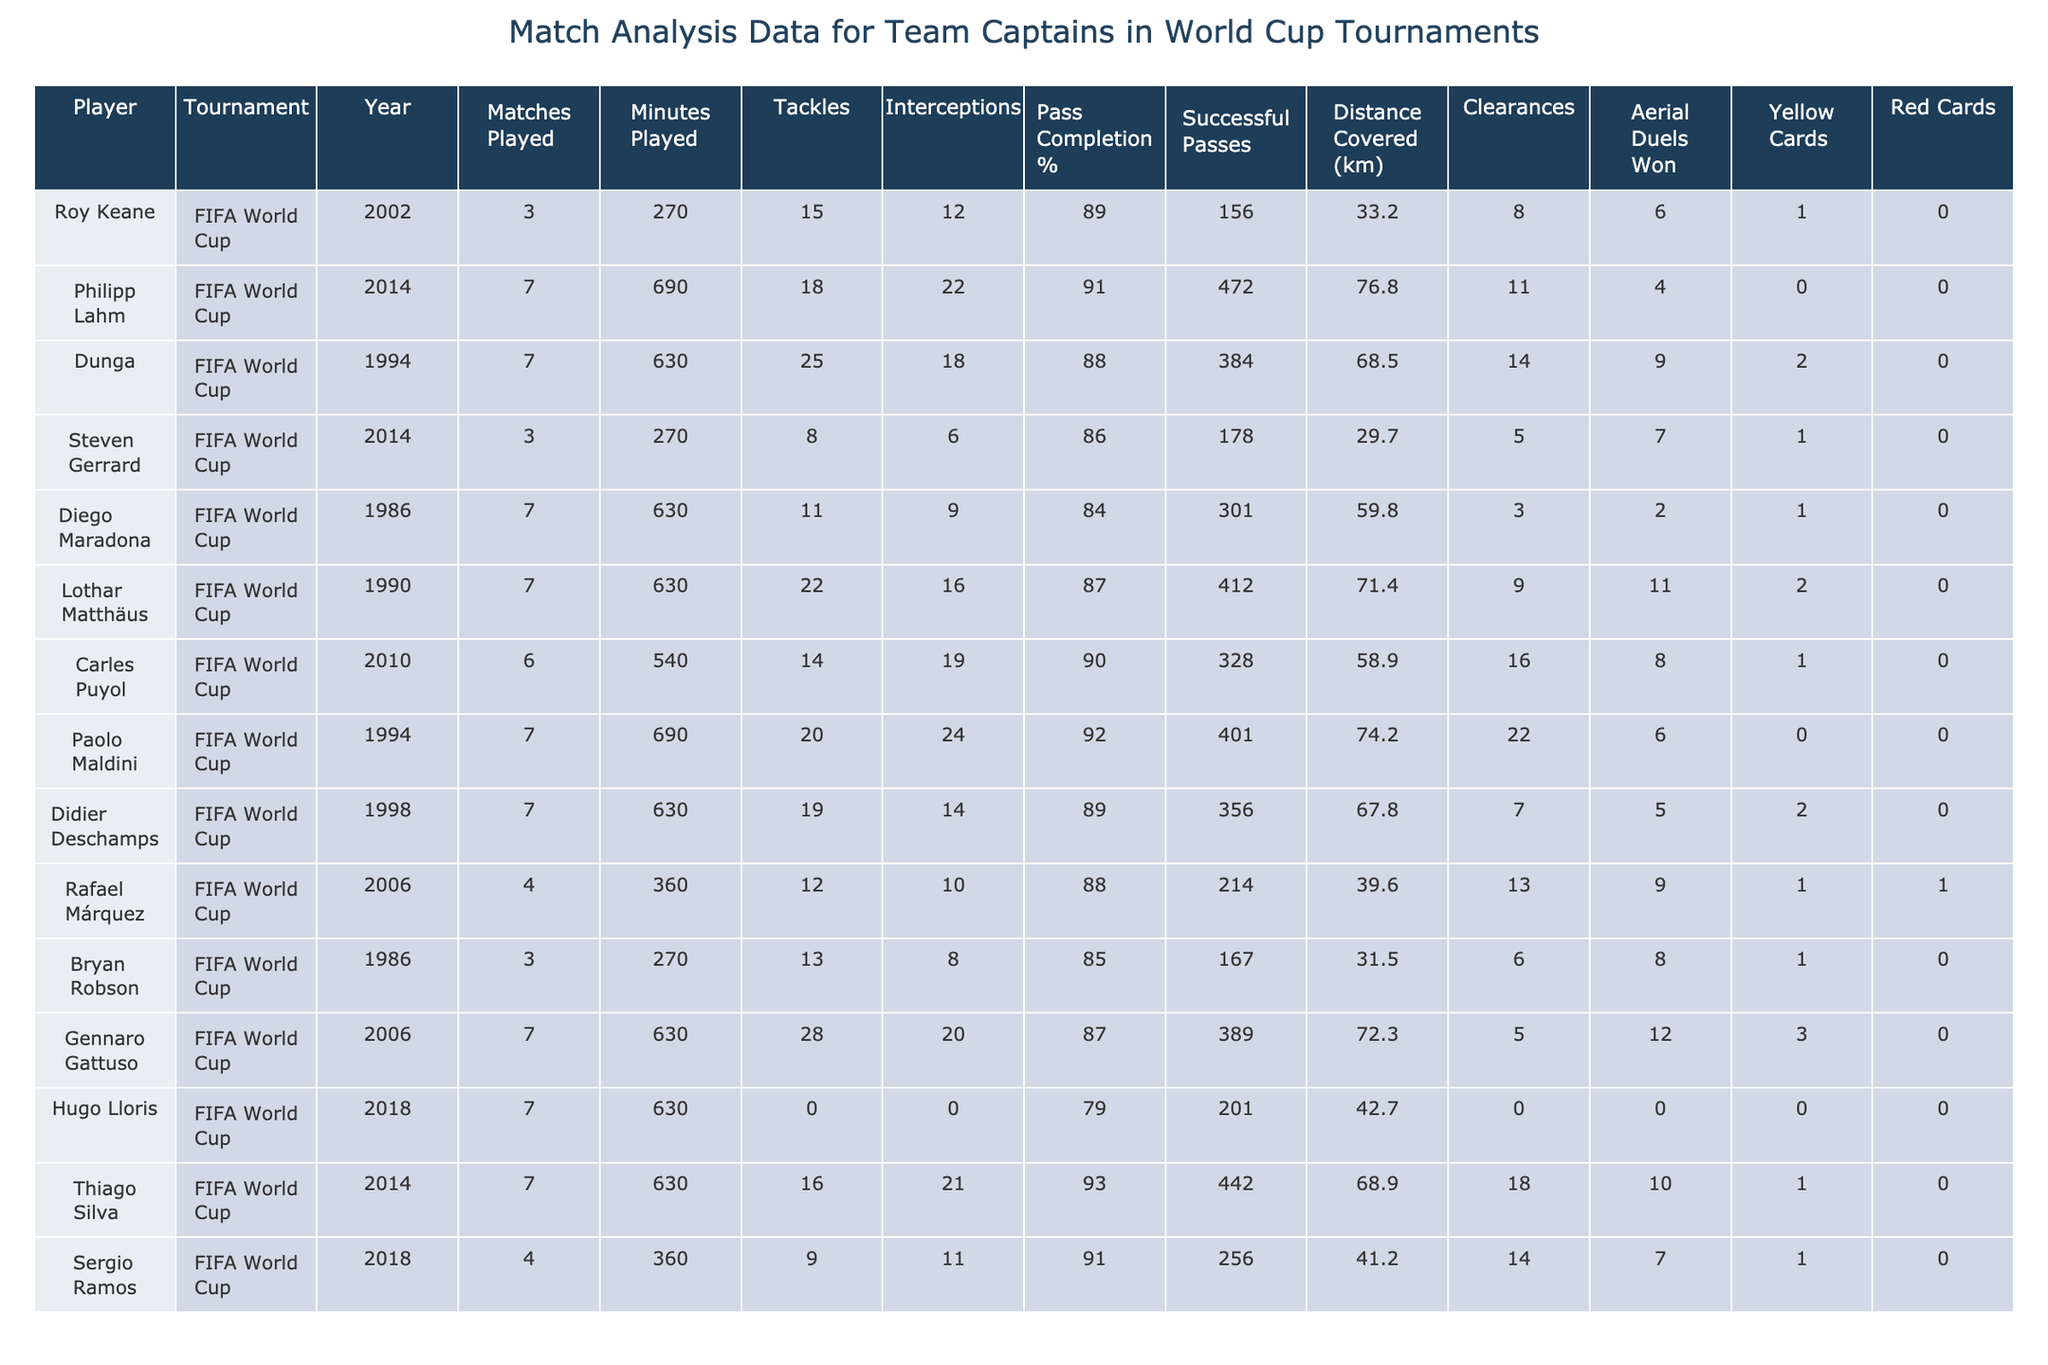What is the total number of matches played by all captains in the 2014 World Cup? The total number of matches can be calculated by adding the matches played by each captain in the 2014 World Cup: Philipp Lahm (7), Steven Gerrard (3), and Thiago Silva (7), which sums up to 7 + 3 + 7 = 17.
Answer: 17 Who made the most tackles in the 1994 World Cup? From the table, Dunga made the most tackles in the 1994 World Cup with a total of 25 tackles.
Answer: 25 Which player has the highest pass completion percentage and what is that percentage? Examining the table, Paolo Maldini has the highest pass completion percentage of 92%.
Answer: 92% How many yellow cards did Gennaro Gattuso receive in the 2006 World Cup? Gennaro Gattuso received 3 yellow cards during the 2006 World Cup as indicated in the table.
Answer: 3 What is the average distance covered by all captains in the 2010 World Cup? To find the average distance, we sum the distances covered by the captains in 2010 (Carles Puyol) which is 58.9 km and divide by the number of captains, which is 1, resulting in an average of 58.9 km.
Answer: 58.9 km Did any player receive a red card in the 2018 World Cup? From the table, Hugo Lloris and Sergio Ramos both have red cards listed as 0, indicating no player received a red card in the 2018 World Cup.
Answer: No Which captain played the most minutes, and how many minutes did they play? Philipp Lahm played the most minutes during the 2014 World Cup, totaling 690 minutes.
Answer: 690 minutes Calculating the total tackles for the captains from the 2006 World Cup gives what result? The total tackles can be calculated from Gennaro Gattuso (28) and Rafael Márquez (12) for the 2006 World Cup, summing up to 28 + 12 = 40 tackles.
Answer: 40 Is it true that we have a player with 0 tackles listed? Looking at the table, Hugo Lloris has 0 tackles recorded, confirming that there is indeed a player with 0 tackles.
Answer: Yes What is the difference in successful passes between Dunga and Sergio Ramos? Dunga made 14 successful passes, and Sergio Ramos made 14 as well. The difference in successful passes between them is 14 - 14 = 0.
Answer: 0 Who was the only player to receive a red card in the dataset provided? Looking at the table, Rafael Márquez stands out with 1 red card, making him the only player with a red card recorded.
Answer: Rafael Márquez 